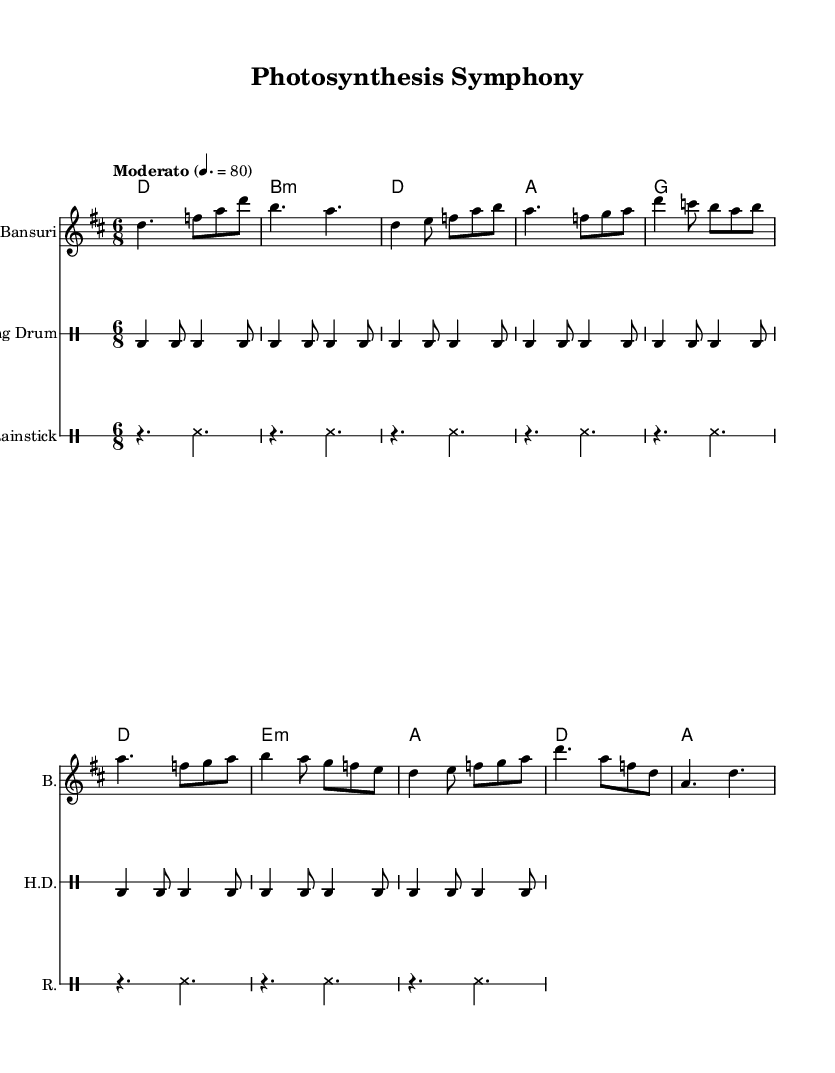What is the key signature of this music? The key signature is D major, which has two sharps (F# and C#). You can identify the key signature by looking at the beginning of the staff, where the sharps are placed.
Answer: D major What is the time signature of the piece? The time signature is 6/8, which is indicated at the beginning of the music and shows there are six eighth notes in each measure.
Answer: 6/8 What is the tempo marking for this composition? The tempo marking is "Moderato" with a metronome marking of 80 beats per minute. This information is placed at the beginning of the sheet music, indicating the speed at which the piece should be played.
Answer: Moderato Which instruments are featured in this score? The score features three instruments: Bansuri, Hang Drum, and Rainstick. This is typically indicated above the staff, showing the name of each instrument.
Answer: Bansuri, Hang Drum, Rainstick How many measures are present in the intro section? The intro section contains 4 measures, as each line corresponds to a segment of music, and a measure is defined by the vertical bar lines. Counting from the start of the intro identifies four complete measures.
Answer: 4 What is the primary motif of the chorus section? The primary motif of the chorus section is built around the notes D, C, B, A, B, and it repeats similar phrases with slight variations in notes. Analyzing the notation during the chorus helps identify this motif.
Answer: D, C, B, A, B How does the harmonization change in the bridge section compared to the verse? In the bridge, the harmonization changes to E minor and then to A major, giving it a different emotional quality compared to the verse, which stays primarily in D major and A major. Noticing the shift in chord changes provides insight into the emotional dynamics of the piece.
Answer: E minor, A major 